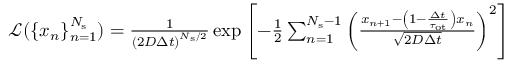Convert formula to latex. <formula><loc_0><loc_0><loc_500><loc_500>\begin{array} { r } { \mathcal { L } ( \{ x _ { n } \} _ { n = 1 } ^ { N _ { s } } ) = \frac { 1 } { \left ( 2 D \Delta t \right ) ^ { N _ { s } / 2 } } \exp \left [ - \frac { 1 } { 2 } \sum _ { n = 1 } ^ { N _ { s } - 1 } \left ( \frac { x _ { n + 1 } - \left ( 1 - \frac { \Delta t } { \tau _ { o t } } \right ) x _ { n } } { \sqrt { 2 D \Delta t } } \right ) ^ { 2 } \right ] } \end{array}</formula> 